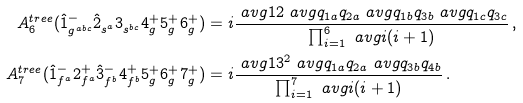Convert formula to latex. <formula><loc_0><loc_0><loc_500><loc_500>A _ { 6 } ^ { t r e e } ( \hat { 1 } ^ { - } _ { g ^ { a b c } } \hat { 2 } ^ { \, } _ { s ^ { a } } 3 ^ { \, } _ { s ^ { b c } } 4 ^ { + } _ { g } 5 ^ { + } _ { g } 6 ^ { + } _ { g } ) & = i \frac { \ a v g { 1 2 } \ a v g { q _ { 1 a } q _ { 2 a } } \ a v g { q _ { 1 b } q _ { 3 b } } \ a v g { q _ { 1 c } q _ { 3 c } } } { \prod _ { i = 1 } ^ { 6 } \ a v g { i ( i + 1 ) } } \, , \\ A _ { 7 } ^ { t r e e } ( \hat { 1 } ^ { - } _ { f ^ { a } } 2 ^ { + } _ { f ^ { a } } \hat { 3 } ^ { - } _ { f ^ { b } } 4 ^ { + } _ { f ^ { b } } 5 ^ { + } _ { g } 6 ^ { + } _ { g } 7 ^ { + } _ { g } ) & = i \frac { \ a v g { 1 3 } ^ { 2 } \ a v g { q _ { 1 a } q _ { 2 a } } \ a v g { q _ { 3 b } q _ { 4 b } } } { \prod _ { i = 1 } ^ { 7 } \ a v g { i ( i + 1 ) } } \, .</formula> 